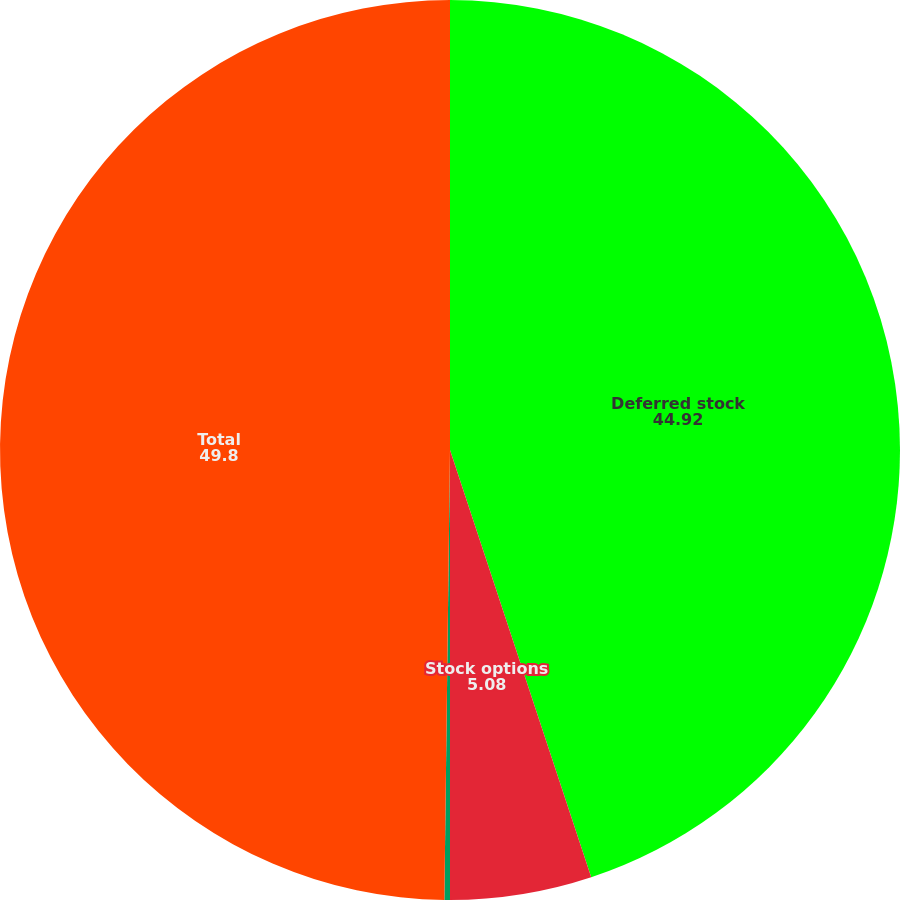Convert chart. <chart><loc_0><loc_0><loc_500><loc_500><pie_chart><fcel>Deferred stock<fcel>Stock options<fcel>Employee Stock Purchase Plan<fcel>Total<nl><fcel>44.92%<fcel>5.08%<fcel>0.2%<fcel>49.8%<nl></chart> 